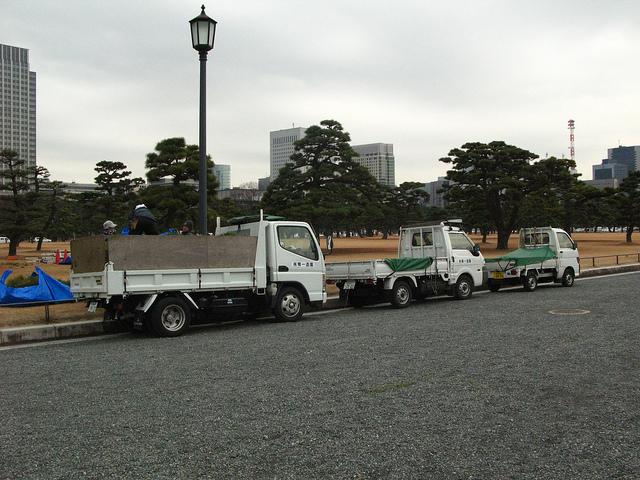Is this a moving truck?
Answer briefly. No. Is there white lines on the asphalt?
Keep it brief. No. Is this a parking lot for bus's?
Write a very short answer. No. Are all of the trucks carrying people in the truck bed?
Write a very short answer. No. How many buildings are behind the truck?
Keep it brief. 6. What is bordering the highway?
Concise answer only. Trucks. Was this picture taken on a farm?
Be succinct. No. 